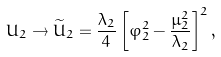<formula> <loc_0><loc_0><loc_500><loc_500>U _ { 2 } \rightarrow \widetilde { U } _ { 2 } = \frac { \lambda _ { 2 } } { 4 } \left [ \varphi _ { 2 } ^ { 2 } - \frac { \mu _ { 2 } ^ { 2 } } { \lambda _ { 2 } } \right ] ^ { 2 } ,</formula> 